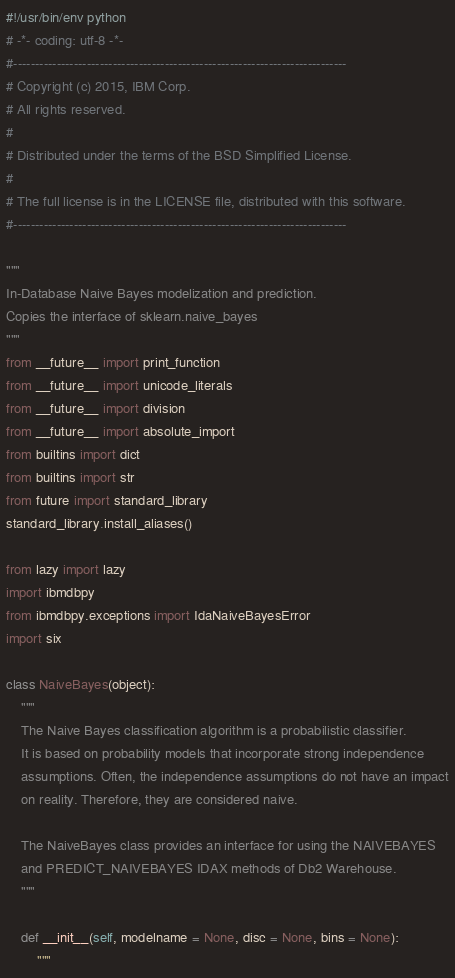<code> <loc_0><loc_0><loc_500><loc_500><_Python_>#!/usr/bin/env python
# -*- coding: utf-8 -*-
#-----------------------------------------------------------------------------
# Copyright (c) 2015, IBM Corp.
# All rights reserved.
#
# Distributed under the terms of the BSD Simplified License.
#
# The full license is in the LICENSE file, distributed with this software.
#-----------------------------------------------------------------------------

"""
In-Database Naive Bayes modelization and prediction.
Copies the interface of sklearn.naive_bayes
"""
from __future__ import print_function
from __future__ import unicode_literals
from __future__ import division
from __future__ import absolute_import
from builtins import dict
from builtins import str
from future import standard_library
standard_library.install_aliases()

from lazy import lazy
import ibmdbpy
from ibmdbpy.exceptions import IdaNaiveBayesError
import six

class NaiveBayes(object):
    """
    The Naive Bayes classification algorithm is a probabilistic classifier.
    It is based on probability models that incorporate strong independence
    assumptions. Often, the independence assumptions do not have an impact
    on reality. Therefore, they are considered naive.

    The NaiveBayes class provides an interface for using the NAIVEBAYES
    and PREDICT_NAIVEBAYES IDAX methods of Db2 Warehouse.
    """

    def __init__(self, modelname = None, disc = None, bins = None):
        """</code> 